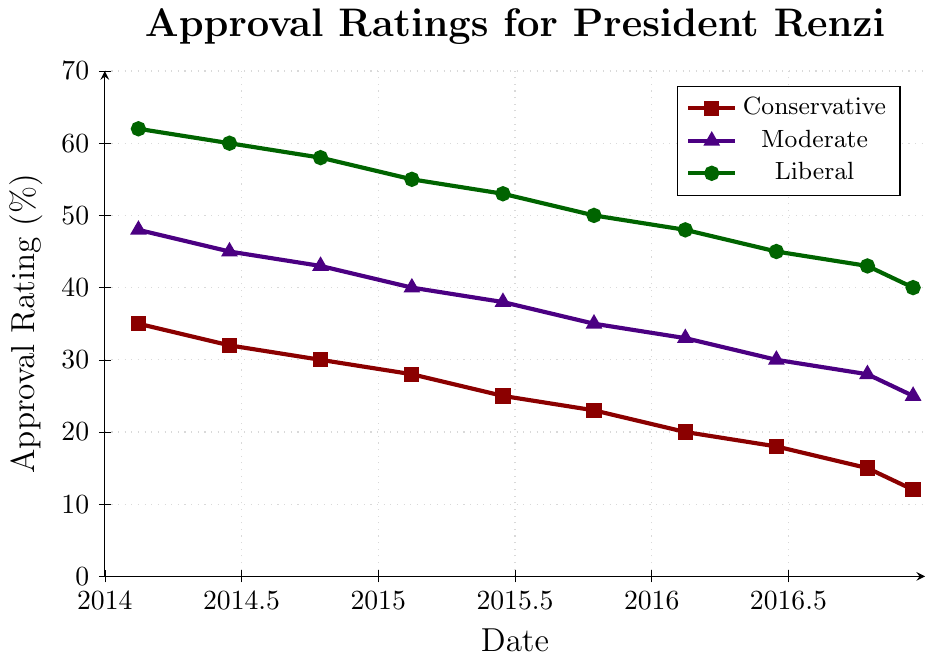What is the approval rating of conservatives and liberals in June 2015? In June 2015, according to the plot, the approval rating for conservatives is at the intersection of the conservative marker and June 2015. The same is applied to liberals. The conservative approval rating is 25%, and the liberal approval rating is 53%.
Answer: Conservatives: 25%, Liberals: 53% How much did the approval rating for moderates decrease from February 2014 to December 2016? In February 2014, the moderate approval rating is at 48%. By December 2016, it is at 25%. Therefore, the decrease in approval rating for moderates is 48% - 25% = 23%.
Answer: 23% Which group had the highest approval rating throughout the term? By reviewing the plot, the group with the highest approval rating throughout the term is easily identifiable by consistently having the top line. The liberals had the highest approval rating at all points depicted in the plot.
Answer: Liberals In what month and year did the conservative approval rating drop below 20%? Observing the conservative line, it dips below the 20% mark between February 2016 and June 2016. The exact date is June 2016.
Answer: June 2016 What was the trend of the approval ratings for all groups from 2014 to 2016? Reviewing the downward slopes of each line from 2014 to 2016 depicts a clear downward trend for all political affiliations. The approval ratings consistently decrease over time for conservatives, moderates, and liberals.
Answer: Downward for all groups Compare the steepness of the decline in approval ratings between conservatives and liberals. Which group had a steeper decline? By comparing the angles of the lines for conservatives and liberals, it is clear that the conservative line declines more sharply. This steeper decline indicates that conservatives had a more significant drop in approval rating over time compared to liberals.
Answer: Conservatives What is the difference in approval ratings between liberals and moderates in October 2015? The approval rating in October 2015 for liberals is 50%, and for moderates, it is 35%. The difference is 50% - 35% = 15%.
Answer: 15% What is the difference in the starting approval rating (February 2014) and ending approval rating (December 2016) for moderates? The starting approval rating for moderates in February 2014 is 48%, and the ending approval rating in December 2016 is 25%. Therefore, the difference is 48% - 25% = 23%.
Answer: 23% What is the average approval rating for conservatives over the entire period? The approval ratings for conservatives over the term are 35%, 32%, 30%, 28%, 25%, 23%, 20%, 18%, 15%, and 12%. To find the average: (35+32+30+28+25+23+20+18+15+12)/10 = 23.8%.
Answer: 23.8% 